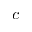<formula> <loc_0><loc_0><loc_500><loc_500>c</formula> 